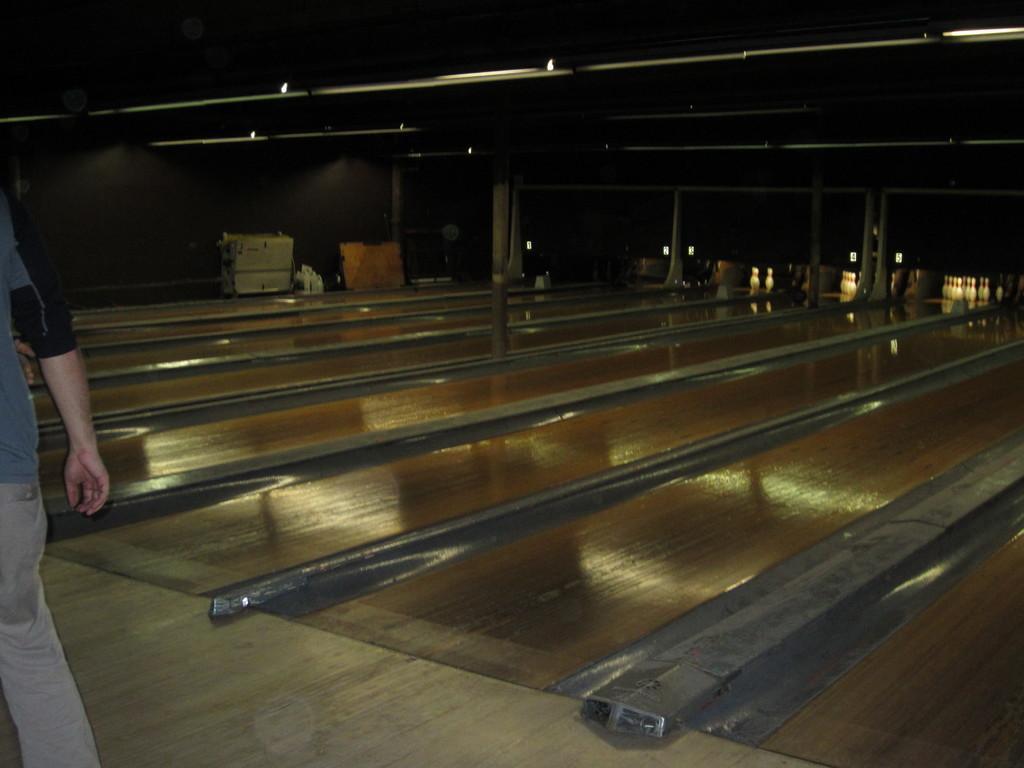Please provide a concise description of this image. In this image I can see a person wearing grey and black colored dress is standing on the floor. I can see the brown colored floor and few white colored objects on the other side of the floor. I can see the black colored ceiling, few lights to the ceiling, the black colored wall and few other objects. 